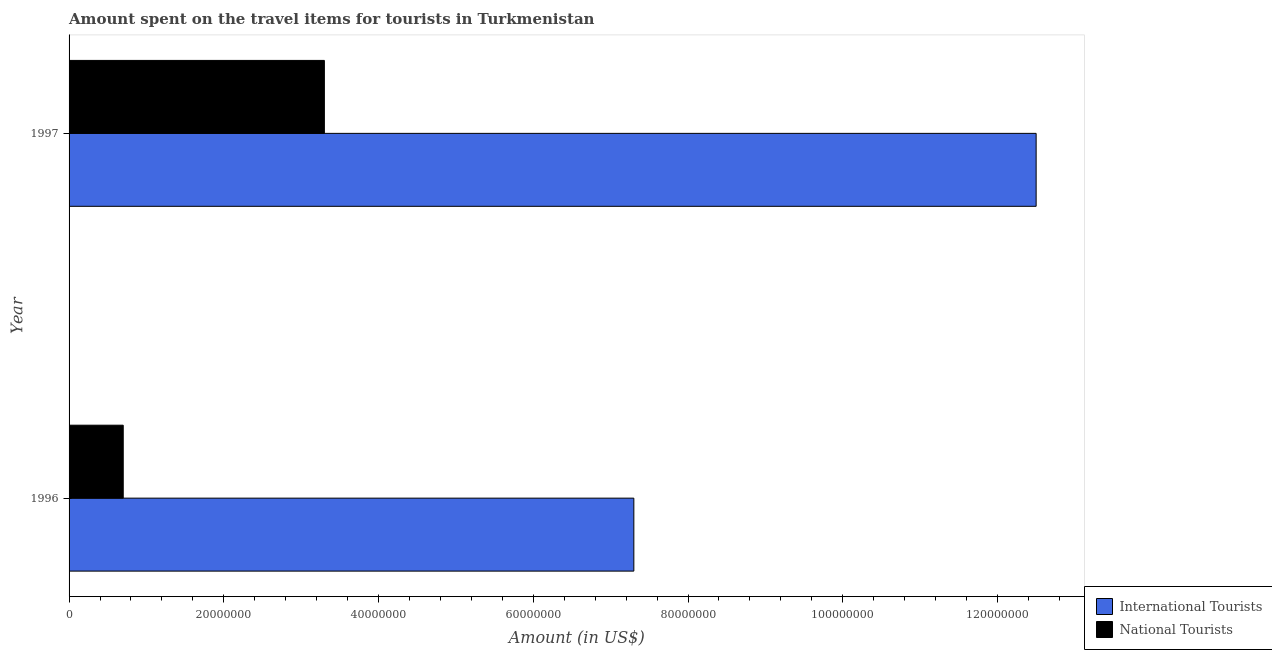How many different coloured bars are there?
Offer a very short reply. 2. Are the number of bars per tick equal to the number of legend labels?
Your answer should be compact. Yes. How many bars are there on the 2nd tick from the bottom?
Provide a succinct answer. 2. What is the amount spent on travel items of national tourists in 1996?
Your answer should be compact. 7.00e+06. Across all years, what is the maximum amount spent on travel items of national tourists?
Offer a terse response. 3.30e+07. Across all years, what is the minimum amount spent on travel items of national tourists?
Provide a succinct answer. 7.00e+06. What is the total amount spent on travel items of international tourists in the graph?
Your answer should be compact. 1.98e+08. What is the difference between the amount spent on travel items of national tourists in 1996 and that in 1997?
Your answer should be compact. -2.60e+07. What is the difference between the amount spent on travel items of national tourists in 1997 and the amount spent on travel items of international tourists in 1996?
Provide a succinct answer. -4.00e+07. What is the average amount spent on travel items of national tourists per year?
Your response must be concise. 2.00e+07. In the year 1997, what is the difference between the amount spent on travel items of international tourists and amount spent on travel items of national tourists?
Keep it short and to the point. 9.20e+07. In how many years, is the amount spent on travel items of international tourists greater than 56000000 US$?
Provide a succinct answer. 2. What is the ratio of the amount spent on travel items of international tourists in 1996 to that in 1997?
Offer a very short reply. 0.58. Is the amount spent on travel items of national tourists in 1996 less than that in 1997?
Provide a succinct answer. Yes. Is the difference between the amount spent on travel items of national tourists in 1996 and 1997 greater than the difference between the amount spent on travel items of international tourists in 1996 and 1997?
Offer a very short reply. Yes. In how many years, is the amount spent on travel items of international tourists greater than the average amount spent on travel items of international tourists taken over all years?
Ensure brevity in your answer.  1. What does the 2nd bar from the top in 1996 represents?
Offer a very short reply. International Tourists. What does the 2nd bar from the bottom in 1996 represents?
Ensure brevity in your answer.  National Tourists. Are all the bars in the graph horizontal?
Make the answer very short. Yes. What is the difference between two consecutive major ticks on the X-axis?
Keep it short and to the point. 2.00e+07. How many legend labels are there?
Give a very brief answer. 2. What is the title of the graph?
Keep it short and to the point. Amount spent on the travel items for tourists in Turkmenistan. What is the label or title of the Y-axis?
Give a very brief answer. Year. What is the Amount (in US$) of International Tourists in 1996?
Provide a succinct answer. 7.30e+07. What is the Amount (in US$) in National Tourists in 1996?
Offer a very short reply. 7.00e+06. What is the Amount (in US$) of International Tourists in 1997?
Provide a succinct answer. 1.25e+08. What is the Amount (in US$) in National Tourists in 1997?
Offer a very short reply. 3.30e+07. Across all years, what is the maximum Amount (in US$) in International Tourists?
Provide a short and direct response. 1.25e+08. Across all years, what is the maximum Amount (in US$) of National Tourists?
Ensure brevity in your answer.  3.30e+07. Across all years, what is the minimum Amount (in US$) of International Tourists?
Offer a terse response. 7.30e+07. Across all years, what is the minimum Amount (in US$) in National Tourists?
Provide a succinct answer. 7.00e+06. What is the total Amount (in US$) of International Tourists in the graph?
Your response must be concise. 1.98e+08. What is the total Amount (in US$) of National Tourists in the graph?
Provide a succinct answer. 4.00e+07. What is the difference between the Amount (in US$) in International Tourists in 1996 and that in 1997?
Keep it short and to the point. -5.20e+07. What is the difference between the Amount (in US$) in National Tourists in 1996 and that in 1997?
Offer a terse response. -2.60e+07. What is the difference between the Amount (in US$) in International Tourists in 1996 and the Amount (in US$) in National Tourists in 1997?
Offer a very short reply. 4.00e+07. What is the average Amount (in US$) in International Tourists per year?
Provide a succinct answer. 9.90e+07. What is the average Amount (in US$) of National Tourists per year?
Give a very brief answer. 2.00e+07. In the year 1996, what is the difference between the Amount (in US$) of International Tourists and Amount (in US$) of National Tourists?
Provide a succinct answer. 6.60e+07. In the year 1997, what is the difference between the Amount (in US$) in International Tourists and Amount (in US$) in National Tourists?
Make the answer very short. 9.20e+07. What is the ratio of the Amount (in US$) of International Tourists in 1996 to that in 1997?
Offer a very short reply. 0.58. What is the ratio of the Amount (in US$) in National Tourists in 1996 to that in 1997?
Keep it short and to the point. 0.21. What is the difference between the highest and the second highest Amount (in US$) in International Tourists?
Make the answer very short. 5.20e+07. What is the difference between the highest and the second highest Amount (in US$) in National Tourists?
Your answer should be very brief. 2.60e+07. What is the difference between the highest and the lowest Amount (in US$) in International Tourists?
Keep it short and to the point. 5.20e+07. What is the difference between the highest and the lowest Amount (in US$) in National Tourists?
Keep it short and to the point. 2.60e+07. 